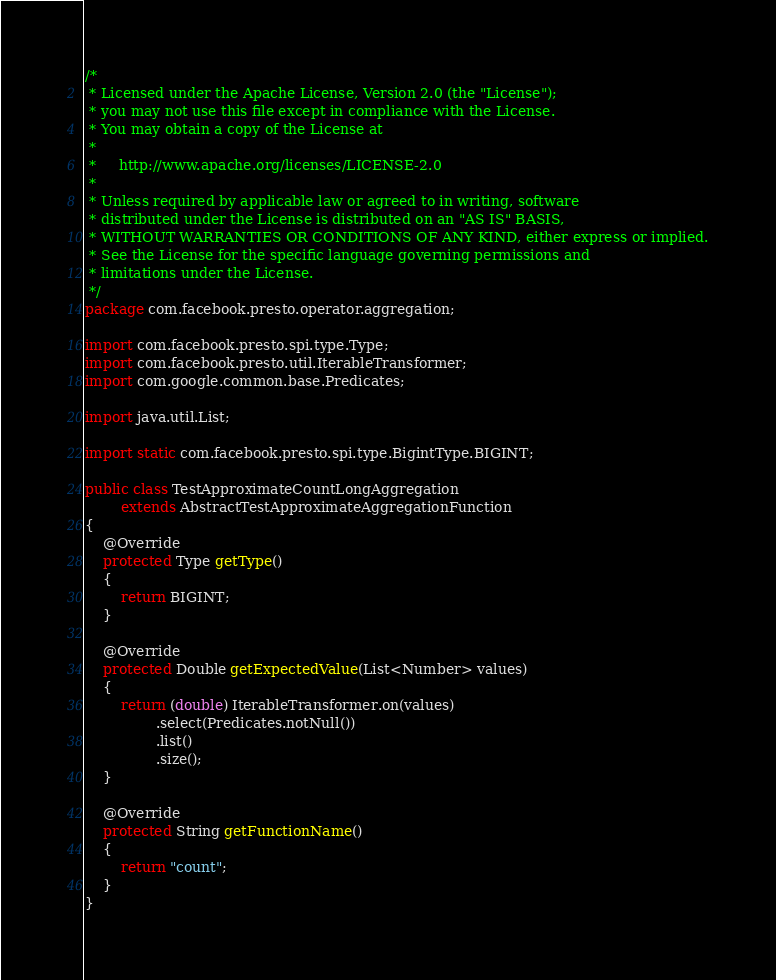Convert code to text. <code><loc_0><loc_0><loc_500><loc_500><_Java_>/*
 * Licensed under the Apache License, Version 2.0 (the "License");
 * you may not use this file except in compliance with the License.
 * You may obtain a copy of the License at
 *
 *     http://www.apache.org/licenses/LICENSE-2.0
 *
 * Unless required by applicable law or agreed to in writing, software
 * distributed under the License is distributed on an "AS IS" BASIS,
 * WITHOUT WARRANTIES OR CONDITIONS OF ANY KIND, either express or implied.
 * See the License for the specific language governing permissions and
 * limitations under the License.
 */
package com.facebook.presto.operator.aggregation;

import com.facebook.presto.spi.type.Type;
import com.facebook.presto.util.IterableTransformer;
import com.google.common.base.Predicates;

import java.util.List;

import static com.facebook.presto.spi.type.BigintType.BIGINT;

public class TestApproximateCountLongAggregation
        extends AbstractTestApproximateAggregationFunction
{
    @Override
    protected Type getType()
    {
        return BIGINT;
    }

    @Override
    protected Double getExpectedValue(List<Number> values)
    {
        return (double) IterableTransformer.on(values)
                .select(Predicates.notNull())
                .list()
                .size();
    }

    @Override
    protected String getFunctionName()
    {
        return "count";
    }
}
</code> 